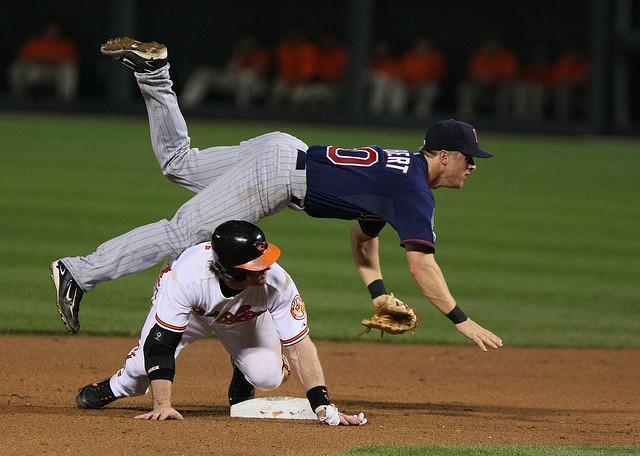How many feet aren't touching the ground?
Give a very brief answer. 2. How many people are in the picture?
Give a very brief answer. 5. How many beds are in the photo?
Give a very brief answer. 0. 